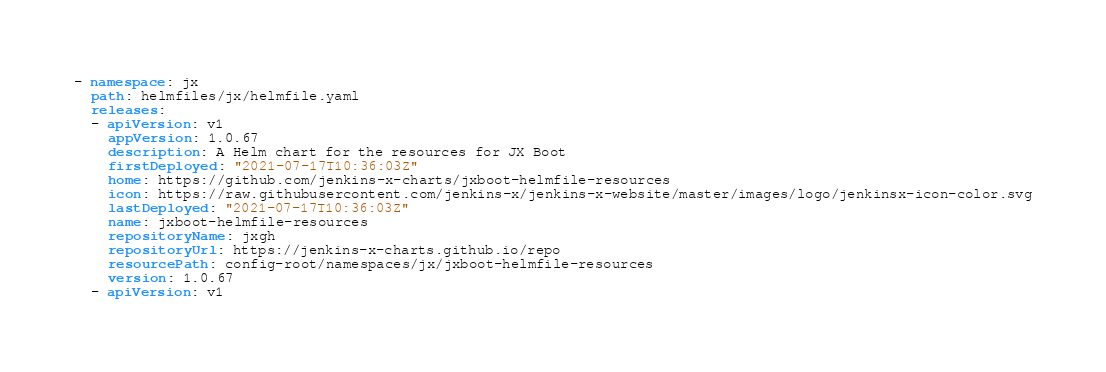<code> <loc_0><loc_0><loc_500><loc_500><_YAML_>- namespace: jx
  path: helmfiles/jx/helmfile.yaml
  releases:
  - apiVersion: v1
    appVersion: 1.0.67
    description: A Helm chart for the resources for JX Boot
    firstDeployed: "2021-07-17T10:36:03Z"
    home: https://github.com/jenkins-x-charts/jxboot-helmfile-resources
    icon: https://raw.githubusercontent.com/jenkins-x/jenkins-x-website/master/images/logo/jenkinsx-icon-color.svg
    lastDeployed: "2021-07-17T10:36:03Z"
    name: jxboot-helmfile-resources
    repositoryName: jxgh
    repositoryUrl: https://jenkins-x-charts.github.io/repo
    resourcePath: config-root/namespaces/jx/jxboot-helmfile-resources
    version: 1.0.67
  - apiVersion: v1</code> 